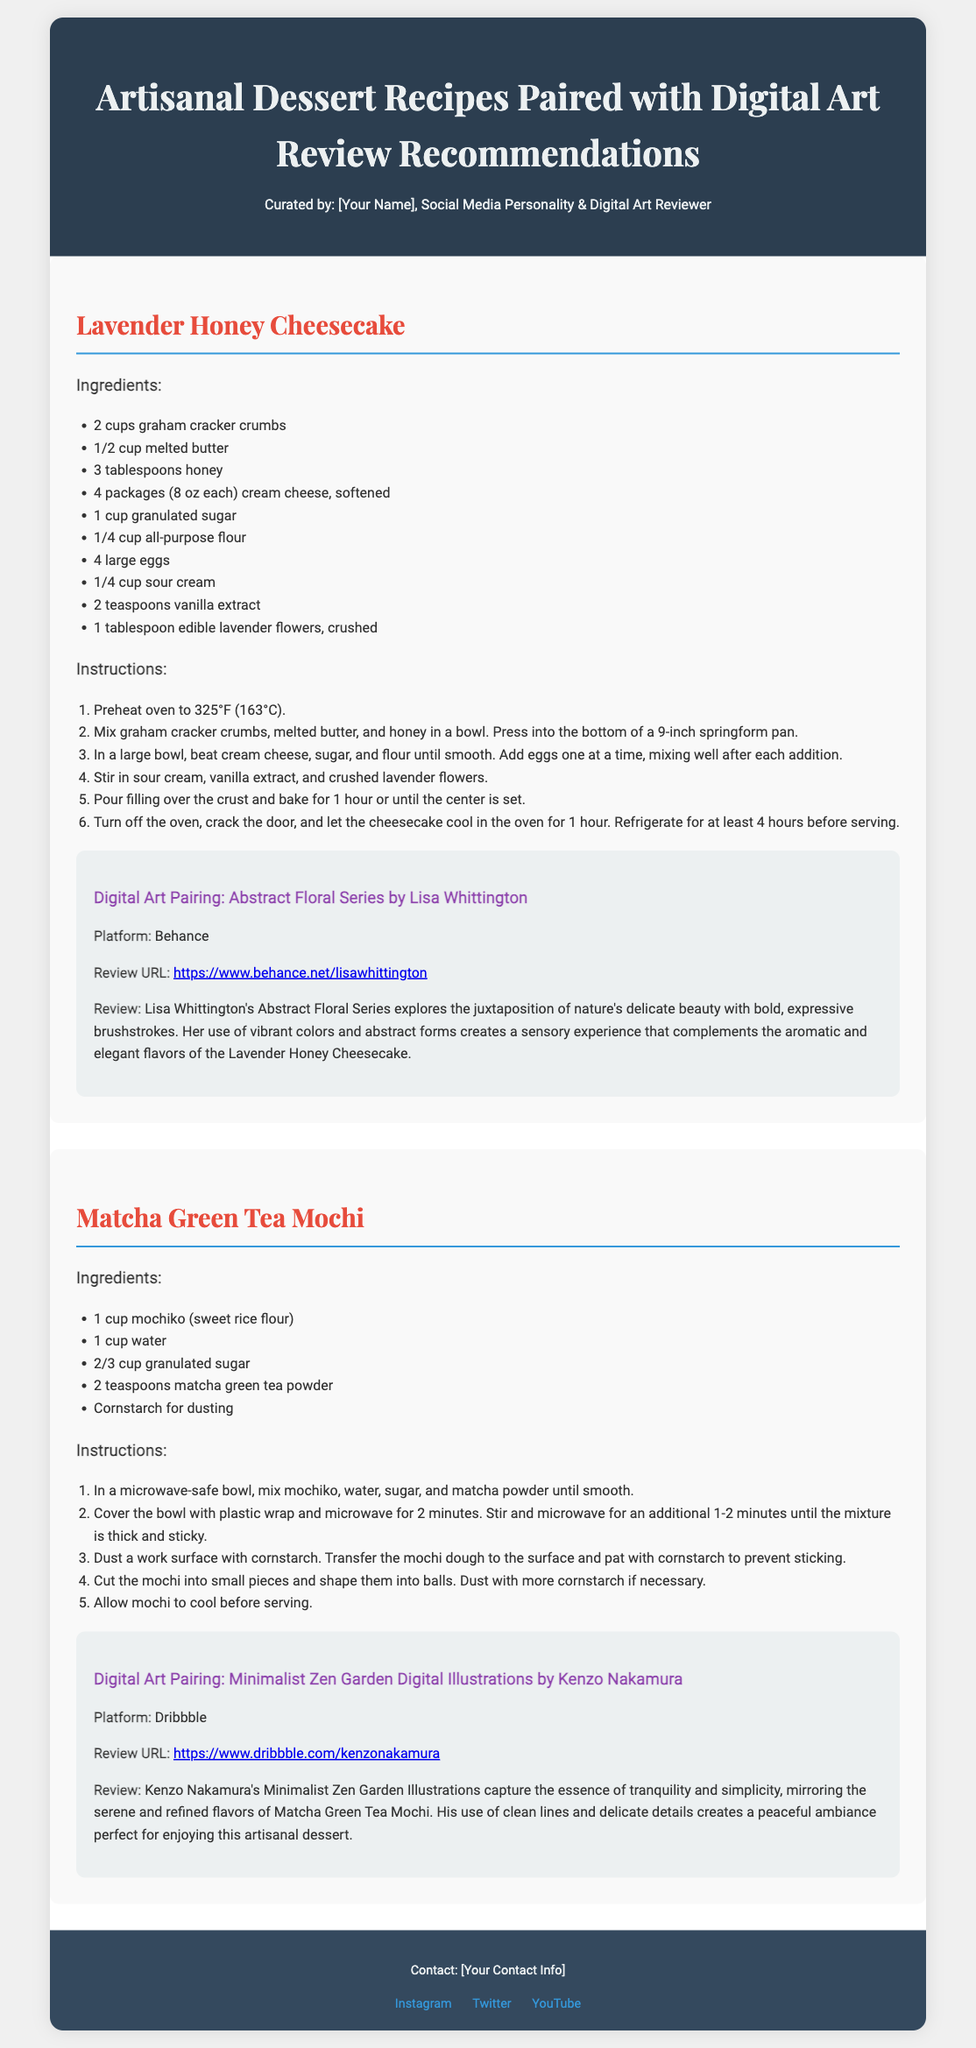What is the name of the first dessert recipe? The dessert recipes include the Lavender Honey Cheesecake and Matcha Green Tea Mochi. The first one listed is Lavender Honey Cheesecake.
Answer: Lavender Honey Cheesecake How many eggs does the Lavender Honey Cheesecake require? The ingredient list for the Lavender Honey Cheesecake includes 4 large eggs.
Answer: 4 large eggs What is the primary color theme used in the document? The background color of the header and other sections suggests a dark blue theme, and the typography features a mix of pastel and darker colors throughout.
Answer: Dark blue What is the cooking temperature for the Lavender Honey Cheesecake? The instructions state to preheat the oven to 325°F (163°C).
Answer: 325°F Who is the digital artist paired with Matcha Green Tea Mochi? The document mentions the digital artist as Kenzo Nakamura who created Minimalist Zen Garden Digital Illustrations.
Answer: Kenzo Nakamura What type of flour is used in Matcha Green Tea Mochi? The ingredient list specifies mochiko, which is a sweet rice flour.
Answer: Mochiko What main theme does Lisa Whittington's Abstract Floral Series explore? The review for the digital art pairing of the Lavender Honey Cheesecake mentions exploring the juxtaposition of nature's delicate beauty.
Answer: Juxtaposition of nature's delicate beauty What sugar measurement is needed for Matcha Green Tea Mochi? The ingredient list requires 2/3 cup of granulated sugar.
Answer: 2/3 cup Which social media platform features Lisa Whittington's artwork? The review states that her work can be found on Behance.
Answer: Behance 